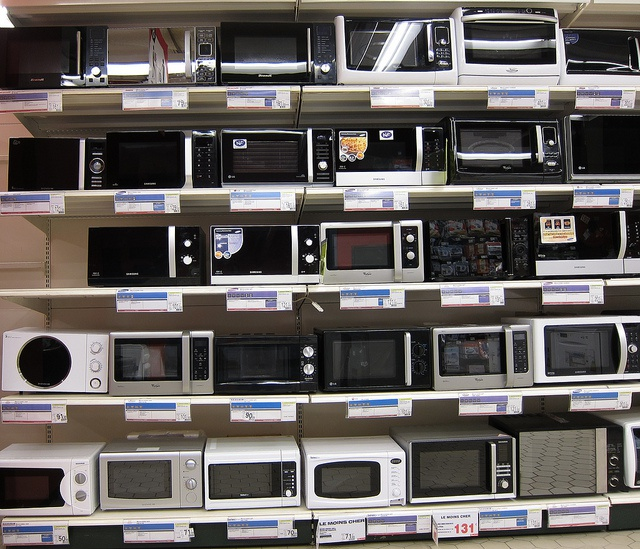Describe the objects in this image and their specific colors. I can see microwave in lightgray, black, gray, and darkgray tones, microwave in lightgray, black, gray, and darkgray tones, microwave in lightgray, darkgray, gray, and black tones, microwave in lightgray, black, gray, and darkgray tones, and microwave in lightgray, black, white, darkgray, and gray tones in this image. 